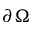<formula> <loc_0><loc_0><loc_500><loc_500>\partial \Omega</formula> 